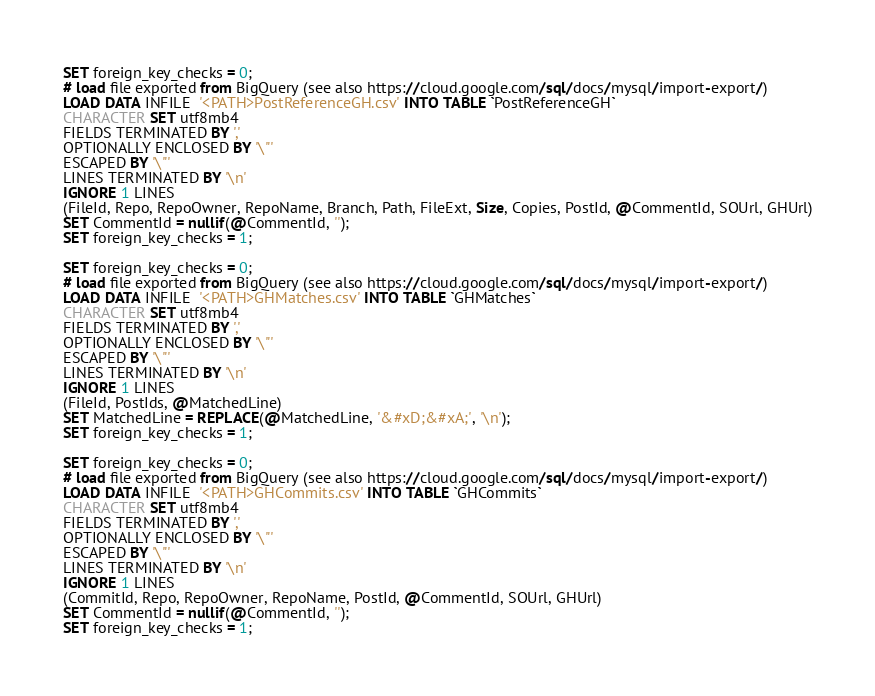Convert code to text. <code><loc_0><loc_0><loc_500><loc_500><_SQL_>SET foreign_key_checks = 0;
# load file exported from BigQuery (see also https://cloud.google.com/sql/docs/mysql/import-export/)
LOAD DATA INFILE  '<PATH>PostReferenceGH.csv' INTO TABLE `PostReferenceGH`
CHARACTER SET utf8mb4
FIELDS TERMINATED BY ','
OPTIONALLY ENCLOSED BY '\"'
ESCAPED BY '\"'
LINES TERMINATED BY '\n'
IGNORE 1 LINES
(FileId, Repo, RepoOwner, RepoName, Branch, Path, FileExt, Size, Copies, PostId, @CommentId, SOUrl, GHUrl)
SET CommentId = nullif(@CommentId, '');
SET foreign_key_checks = 1;

SET foreign_key_checks = 0;
# load file exported from BigQuery (see also https://cloud.google.com/sql/docs/mysql/import-export/)
LOAD DATA INFILE  '<PATH>GHMatches.csv' INTO TABLE `GHMatches`
CHARACTER SET utf8mb4
FIELDS TERMINATED BY ','
OPTIONALLY ENCLOSED BY '\"'
ESCAPED BY '\"'
LINES TERMINATED BY '\n'
IGNORE 1 LINES
(FileId, PostIds, @MatchedLine)
SET MatchedLine = REPLACE(@MatchedLine, '&#xD;&#xA;', '\n');
SET foreign_key_checks = 1;

SET foreign_key_checks = 0;
# load file exported from BigQuery (see also https://cloud.google.com/sql/docs/mysql/import-export/)
LOAD DATA INFILE  '<PATH>GHCommits.csv' INTO TABLE `GHCommits`
CHARACTER SET utf8mb4
FIELDS TERMINATED BY ','
OPTIONALLY ENCLOSED BY '\"'
ESCAPED BY '\"'
LINES TERMINATED BY '\n'
IGNORE 1 LINES
(CommitId, Repo, RepoOwner, RepoName, PostId, @CommentId, SOUrl, GHUrl)
SET CommentId = nullif(@CommentId, '');
SET foreign_key_checks = 1;
</code> 